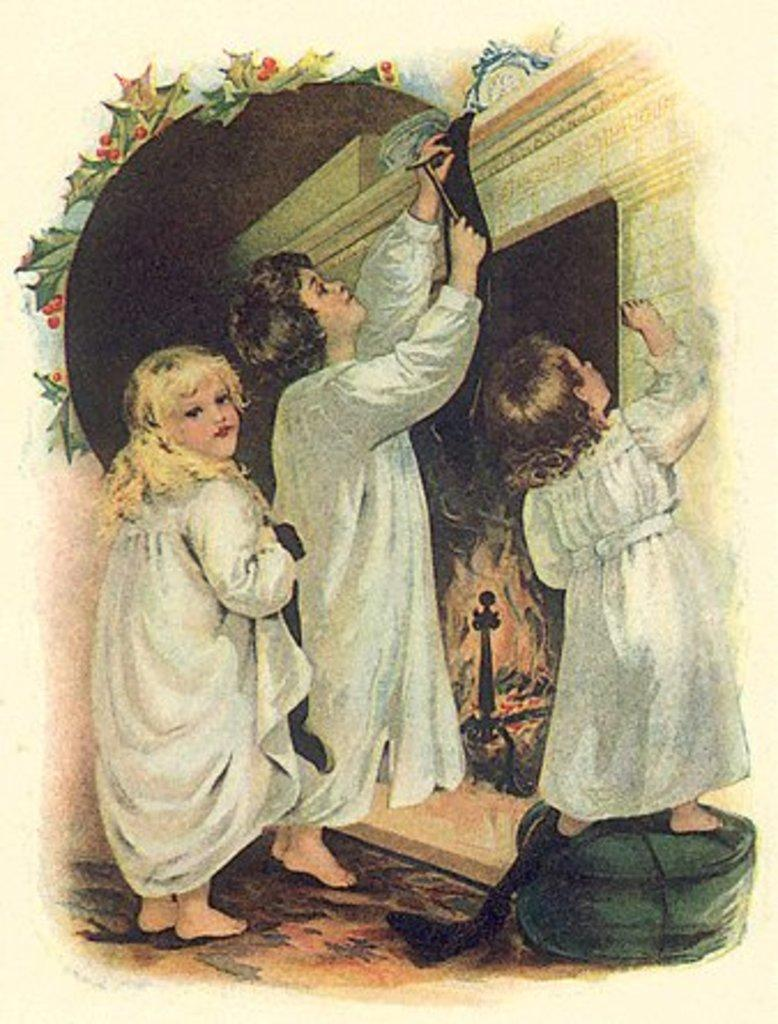How many children are present in the image? There are three children in the image. What are the children doing in the image? The children are standing beside a wall. Can you describe any objects the children are holding? One child is holding a hammer. What type of curtain can be seen hanging from the wall in the image? There is no curtain present in the image; the children are standing beside a wall without any curtains. 